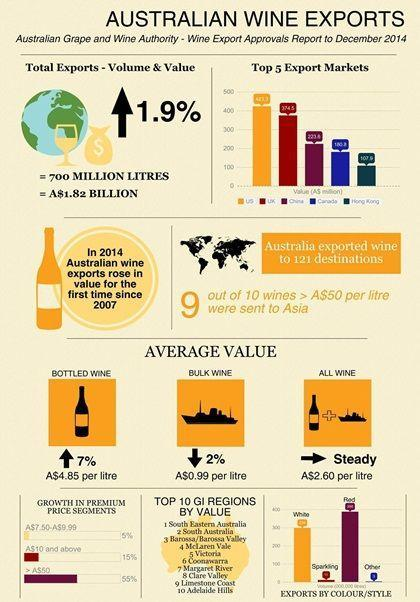what was the value of total exports
Answer the question with a short phrase. A$1.82 billion the average value if which wine increased bottled wine compared to which year, did the wine export increase in 2014 2007 what was the volume of total exports 700 million litres the average value if which wine decreased bulk wine what has been the increase in total exports 1.9% 